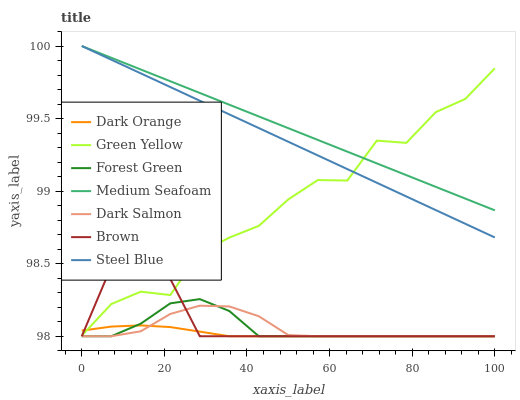Does Brown have the minimum area under the curve?
Answer yes or no. No. Does Brown have the maximum area under the curve?
Answer yes or no. No. Is Brown the smoothest?
Answer yes or no. No. Is Brown the roughest?
Answer yes or no. No. Does Steel Blue have the lowest value?
Answer yes or no. No. Does Brown have the highest value?
Answer yes or no. No. Is Dark Orange less than Medium Seafoam?
Answer yes or no. Yes. Is Steel Blue greater than Brown?
Answer yes or no. Yes. Does Dark Orange intersect Medium Seafoam?
Answer yes or no. No. 